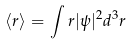<formula> <loc_0><loc_0><loc_500><loc_500>\langle r \rangle = \int r | \psi | ^ { 2 } d ^ { 3 } r</formula> 